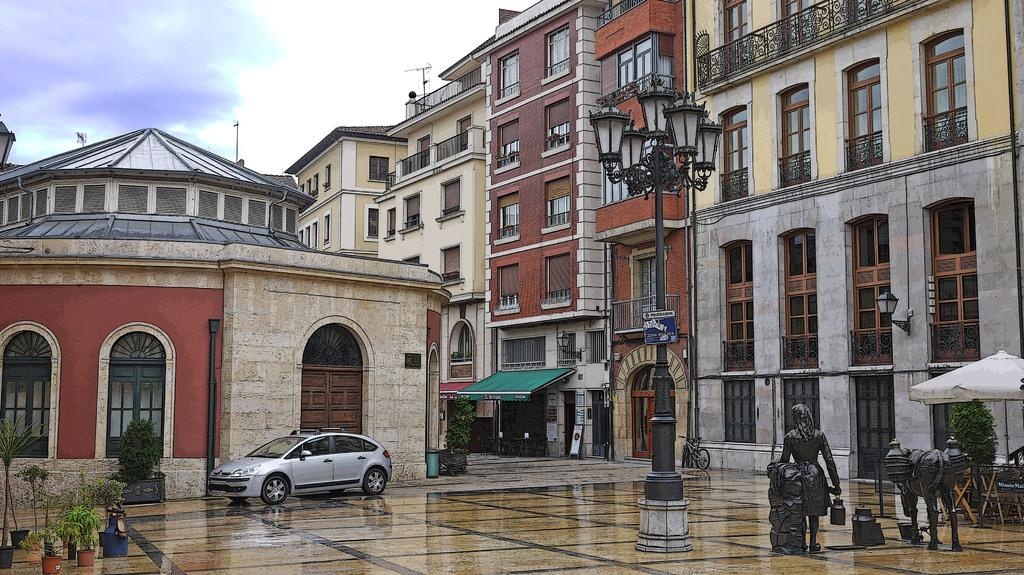What type of vehicle is on the ground in the image? There is a car on the ground in the image. What other objects can be seen in the image? There is a pole, a sun shade, statues, an umbrella, house plants, and buildings with windows in the image. What is the weather like in the image? The sky with clouds is visible in the background of the image, suggesting a partly cloudy day. How many legs can be seen on the bread in the image? There is no bread present in the image, and therefore no legs can be seen on it. 